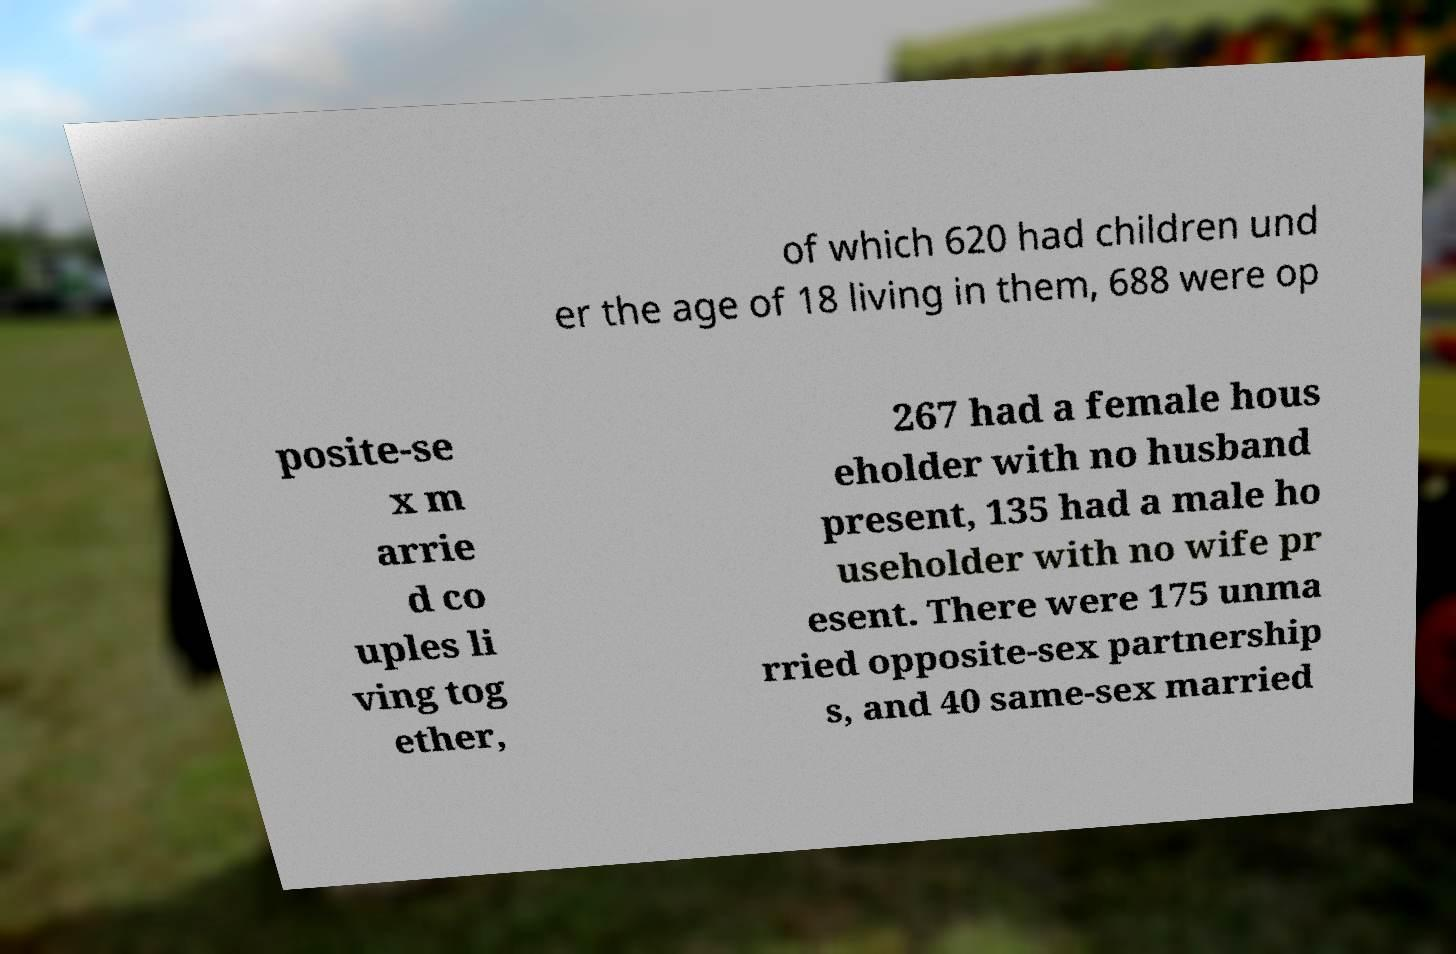Can you read and provide the text displayed in the image?This photo seems to have some interesting text. Can you extract and type it out for me? of which 620 had children und er the age of 18 living in them, 688 were op posite-se x m arrie d co uples li ving tog ether, 267 had a female hous eholder with no husband present, 135 had a male ho useholder with no wife pr esent. There were 175 unma rried opposite-sex partnership s, and 40 same-sex married 